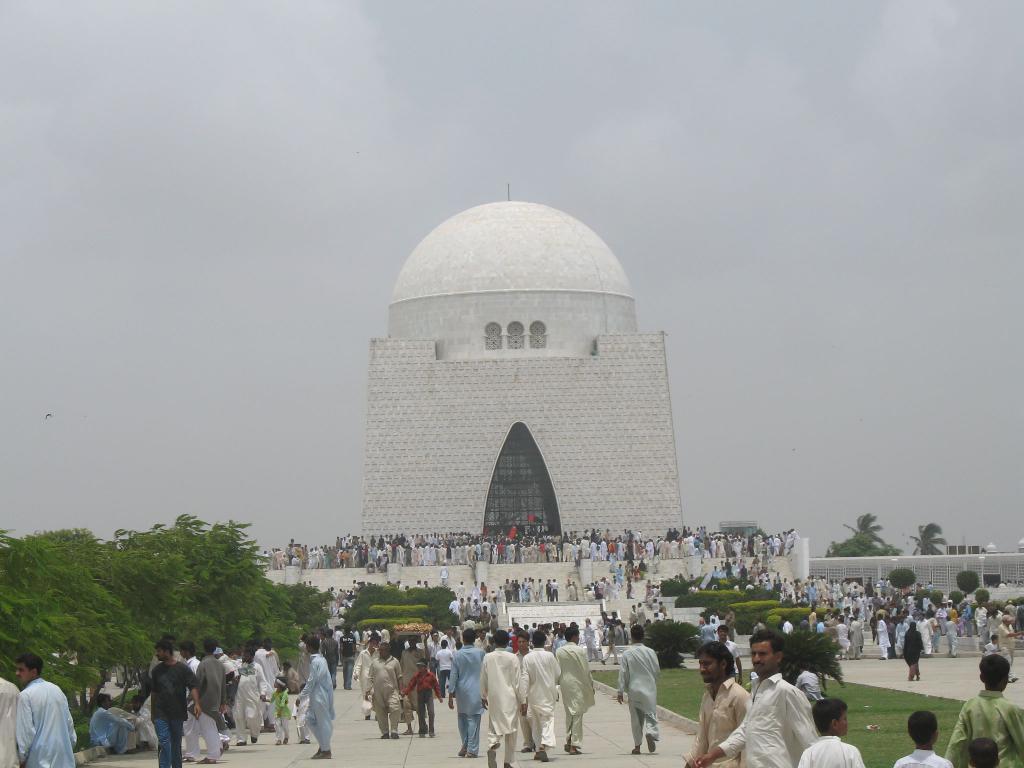Can you describe this image briefly? In this image there is a mosque in the middle. In front of the mosque there are so many people who are standing on the floor. At the bottom there are some people walking on the floor. On the left side there are trees. At the top there is sky. 